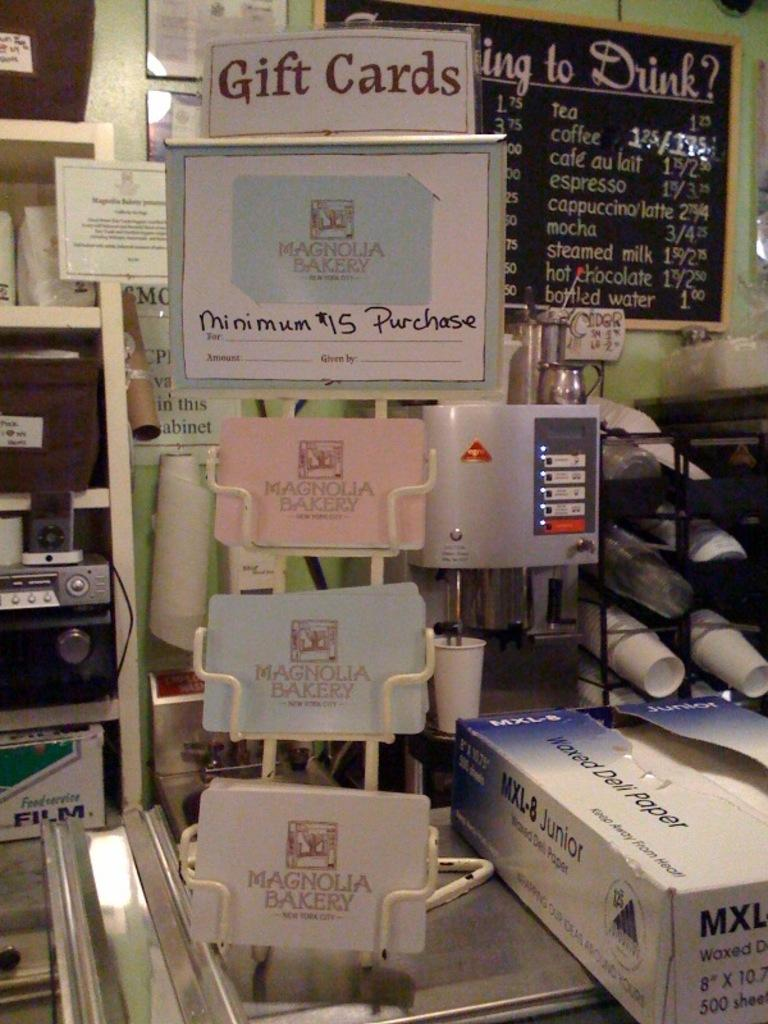Provide a one-sentence caption for the provided image. Gift cards shown in a shop with many items. 